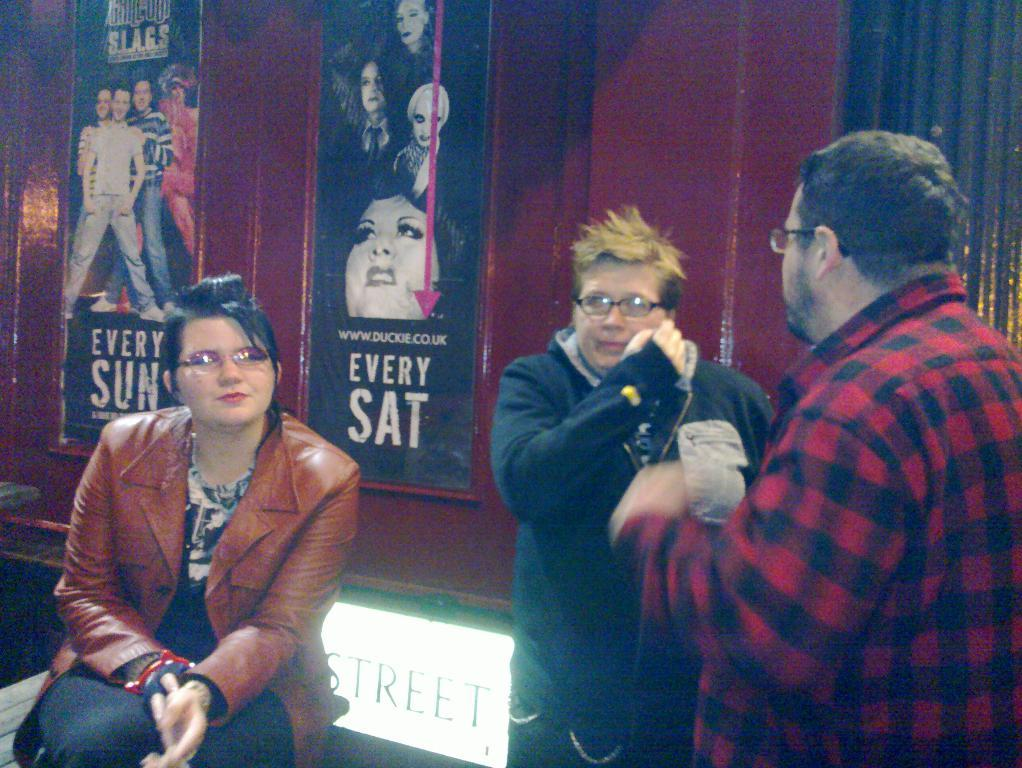What is the lady in the image doing? The lady is sitting on a bench in the image. Who is with the lady in the image? There are two men standing beside the lady. What can be seen in the background of the image? There is a wall with movie posters in the background. What type of joke is the lady telling the men in the image? There is no indication in the image that the lady is telling a joke or that the men are listening to one. 